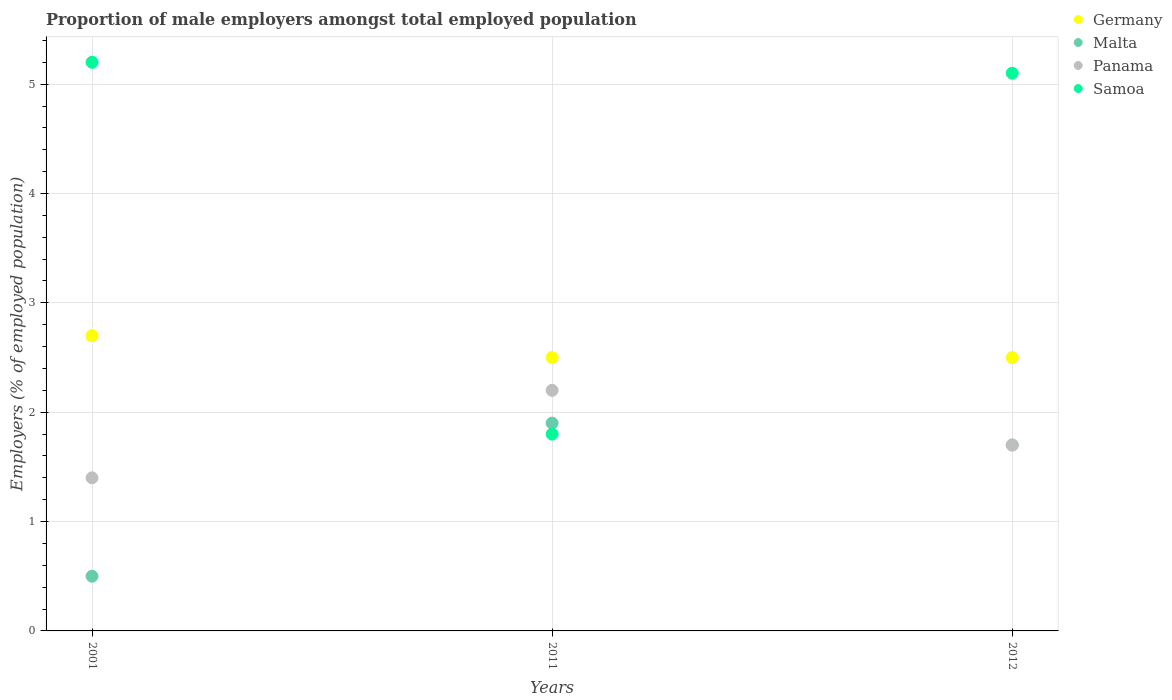How many different coloured dotlines are there?
Keep it short and to the point. 4. What is the proportion of male employers in Malta in 2012?
Keep it short and to the point. 1.7. Across all years, what is the maximum proportion of male employers in Germany?
Your response must be concise. 2.7. Across all years, what is the minimum proportion of male employers in Samoa?
Your response must be concise. 1.8. In which year was the proportion of male employers in Samoa minimum?
Your response must be concise. 2011. What is the total proportion of male employers in Samoa in the graph?
Provide a short and direct response. 12.1. What is the difference between the proportion of male employers in Panama in 2001 and that in 2011?
Give a very brief answer. -0.8. What is the difference between the proportion of male employers in Malta in 2011 and the proportion of male employers in Germany in 2001?
Ensure brevity in your answer.  -0.8. What is the average proportion of male employers in Malta per year?
Offer a terse response. 1.37. In the year 2001, what is the difference between the proportion of male employers in Malta and proportion of male employers in Samoa?
Provide a succinct answer. -4.7. What is the ratio of the proportion of male employers in Germany in 2001 to that in 2011?
Keep it short and to the point. 1.08. Is the difference between the proportion of male employers in Malta in 2011 and 2012 greater than the difference between the proportion of male employers in Samoa in 2011 and 2012?
Your response must be concise. Yes. What is the difference between the highest and the second highest proportion of male employers in Malta?
Your answer should be compact. 0.2. What is the difference between the highest and the lowest proportion of male employers in Malta?
Give a very brief answer. 1.4. In how many years, is the proportion of male employers in Samoa greater than the average proportion of male employers in Samoa taken over all years?
Provide a short and direct response. 2. Is it the case that in every year, the sum of the proportion of male employers in Samoa and proportion of male employers in Malta  is greater than the sum of proportion of male employers in Panama and proportion of male employers in Germany?
Your answer should be very brief. No. Is the proportion of male employers in Malta strictly greater than the proportion of male employers in Panama over the years?
Your answer should be compact. No. How many dotlines are there?
Offer a very short reply. 4. Does the graph contain grids?
Keep it short and to the point. Yes. How many legend labels are there?
Provide a succinct answer. 4. What is the title of the graph?
Offer a very short reply. Proportion of male employers amongst total employed population. Does "Guinea" appear as one of the legend labels in the graph?
Ensure brevity in your answer.  No. What is the label or title of the X-axis?
Your response must be concise. Years. What is the label or title of the Y-axis?
Your answer should be compact. Employers (% of employed population). What is the Employers (% of employed population) of Germany in 2001?
Your response must be concise. 2.7. What is the Employers (% of employed population) in Panama in 2001?
Give a very brief answer. 1.4. What is the Employers (% of employed population) in Samoa in 2001?
Give a very brief answer. 5.2. What is the Employers (% of employed population) of Germany in 2011?
Make the answer very short. 2.5. What is the Employers (% of employed population) of Malta in 2011?
Your answer should be compact. 1.9. What is the Employers (% of employed population) of Panama in 2011?
Offer a very short reply. 2.2. What is the Employers (% of employed population) in Samoa in 2011?
Offer a terse response. 1.8. What is the Employers (% of employed population) of Malta in 2012?
Give a very brief answer. 1.7. What is the Employers (% of employed population) of Panama in 2012?
Offer a terse response. 1.7. What is the Employers (% of employed population) of Samoa in 2012?
Offer a terse response. 5.1. Across all years, what is the maximum Employers (% of employed population) of Germany?
Give a very brief answer. 2.7. Across all years, what is the maximum Employers (% of employed population) in Malta?
Keep it short and to the point. 1.9. Across all years, what is the maximum Employers (% of employed population) of Panama?
Ensure brevity in your answer.  2.2. Across all years, what is the maximum Employers (% of employed population) in Samoa?
Your answer should be compact. 5.2. Across all years, what is the minimum Employers (% of employed population) in Germany?
Give a very brief answer. 2.5. Across all years, what is the minimum Employers (% of employed population) in Panama?
Give a very brief answer. 1.4. Across all years, what is the minimum Employers (% of employed population) of Samoa?
Offer a terse response. 1.8. What is the total Employers (% of employed population) in Germany in the graph?
Make the answer very short. 7.7. What is the total Employers (% of employed population) of Malta in the graph?
Your response must be concise. 4.1. What is the difference between the Employers (% of employed population) in Panama in 2001 and that in 2011?
Make the answer very short. -0.8. What is the difference between the Employers (% of employed population) in Malta in 2001 and that in 2012?
Ensure brevity in your answer.  -1.2. What is the difference between the Employers (% of employed population) of Germany in 2011 and that in 2012?
Your answer should be very brief. 0. What is the difference between the Employers (% of employed population) in Malta in 2011 and that in 2012?
Your answer should be very brief. 0.2. What is the difference between the Employers (% of employed population) of Panama in 2011 and that in 2012?
Provide a succinct answer. 0.5. What is the difference between the Employers (% of employed population) of Samoa in 2011 and that in 2012?
Provide a short and direct response. -3.3. What is the difference between the Employers (% of employed population) in Germany in 2001 and the Employers (% of employed population) in Panama in 2011?
Offer a terse response. 0.5. What is the difference between the Employers (% of employed population) in Germany in 2001 and the Employers (% of employed population) in Samoa in 2011?
Provide a succinct answer. 0.9. What is the difference between the Employers (% of employed population) of Panama in 2001 and the Employers (% of employed population) of Samoa in 2011?
Ensure brevity in your answer.  -0.4. What is the difference between the Employers (% of employed population) of Germany in 2001 and the Employers (% of employed population) of Panama in 2012?
Give a very brief answer. 1. What is the difference between the Employers (% of employed population) of Malta in 2001 and the Employers (% of employed population) of Panama in 2012?
Ensure brevity in your answer.  -1.2. What is the difference between the Employers (% of employed population) of Malta in 2001 and the Employers (% of employed population) of Samoa in 2012?
Give a very brief answer. -4.6. What is the difference between the Employers (% of employed population) of Germany in 2011 and the Employers (% of employed population) of Malta in 2012?
Your response must be concise. 0.8. What is the average Employers (% of employed population) of Germany per year?
Offer a very short reply. 2.57. What is the average Employers (% of employed population) of Malta per year?
Offer a very short reply. 1.37. What is the average Employers (% of employed population) in Panama per year?
Offer a terse response. 1.77. What is the average Employers (% of employed population) of Samoa per year?
Your answer should be very brief. 4.03. In the year 2001, what is the difference between the Employers (% of employed population) in Germany and Employers (% of employed population) in Malta?
Give a very brief answer. 2.2. In the year 2001, what is the difference between the Employers (% of employed population) in Germany and Employers (% of employed population) in Samoa?
Make the answer very short. -2.5. In the year 2001, what is the difference between the Employers (% of employed population) of Malta and Employers (% of employed population) of Samoa?
Your answer should be compact. -4.7. In the year 2011, what is the difference between the Employers (% of employed population) of Germany and Employers (% of employed population) of Malta?
Offer a terse response. 0.6. In the year 2011, what is the difference between the Employers (% of employed population) in Germany and Employers (% of employed population) in Panama?
Ensure brevity in your answer.  0.3. In the year 2011, what is the difference between the Employers (% of employed population) in Germany and Employers (% of employed population) in Samoa?
Provide a succinct answer. 0.7. In the year 2011, what is the difference between the Employers (% of employed population) in Malta and Employers (% of employed population) in Panama?
Provide a short and direct response. -0.3. In the year 2011, what is the difference between the Employers (% of employed population) of Panama and Employers (% of employed population) of Samoa?
Provide a succinct answer. 0.4. In the year 2012, what is the difference between the Employers (% of employed population) of Germany and Employers (% of employed population) of Malta?
Offer a terse response. 0.8. In the year 2012, what is the difference between the Employers (% of employed population) of Germany and Employers (% of employed population) of Panama?
Give a very brief answer. 0.8. In the year 2012, what is the difference between the Employers (% of employed population) of Germany and Employers (% of employed population) of Samoa?
Give a very brief answer. -2.6. In the year 2012, what is the difference between the Employers (% of employed population) in Panama and Employers (% of employed population) in Samoa?
Make the answer very short. -3.4. What is the ratio of the Employers (% of employed population) of Malta in 2001 to that in 2011?
Give a very brief answer. 0.26. What is the ratio of the Employers (% of employed population) of Panama in 2001 to that in 2011?
Ensure brevity in your answer.  0.64. What is the ratio of the Employers (% of employed population) in Samoa in 2001 to that in 2011?
Keep it short and to the point. 2.89. What is the ratio of the Employers (% of employed population) in Germany in 2001 to that in 2012?
Make the answer very short. 1.08. What is the ratio of the Employers (% of employed population) of Malta in 2001 to that in 2012?
Your response must be concise. 0.29. What is the ratio of the Employers (% of employed population) of Panama in 2001 to that in 2012?
Keep it short and to the point. 0.82. What is the ratio of the Employers (% of employed population) of Samoa in 2001 to that in 2012?
Your response must be concise. 1.02. What is the ratio of the Employers (% of employed population) in Germany in 2011 to that in 2012?
Your response must be concise. 1. What is the ratio of the Employers (% of employed population) of Malta in 2011 to that in 2012?
Offer a very short reply. 1.12. What is the ratio of the Employers (% of employed population) of Panama in 2011 to that in 2012?
Keep it short and to the point. 1.29. What is the ratio of the Employers (% of employed population) in Samoa in 2011 to that in 2012?
Provide a succinct answer. 0.35. What is the difference between the highest and the second highest Employers (% of employed population) in Germany?
Your response must be concise. 0.2. What is the difference between the highest and the second highest Employers (% of employed population) in Samoa?
Your answer should be very brief. 0.1. What is the difference between the highest and the lowest Employers (% of employed population) of Germany?
Keep it short and to the point. 0.2. What is the difference between the highest and the lowest Employers (% of employed population) of Malta?
Your answer should be very brief. 1.4. What is the difference between the highest and the lowest Employers (% of employed population) of Panama?
Ensure brevity in your answer.  0.8. 